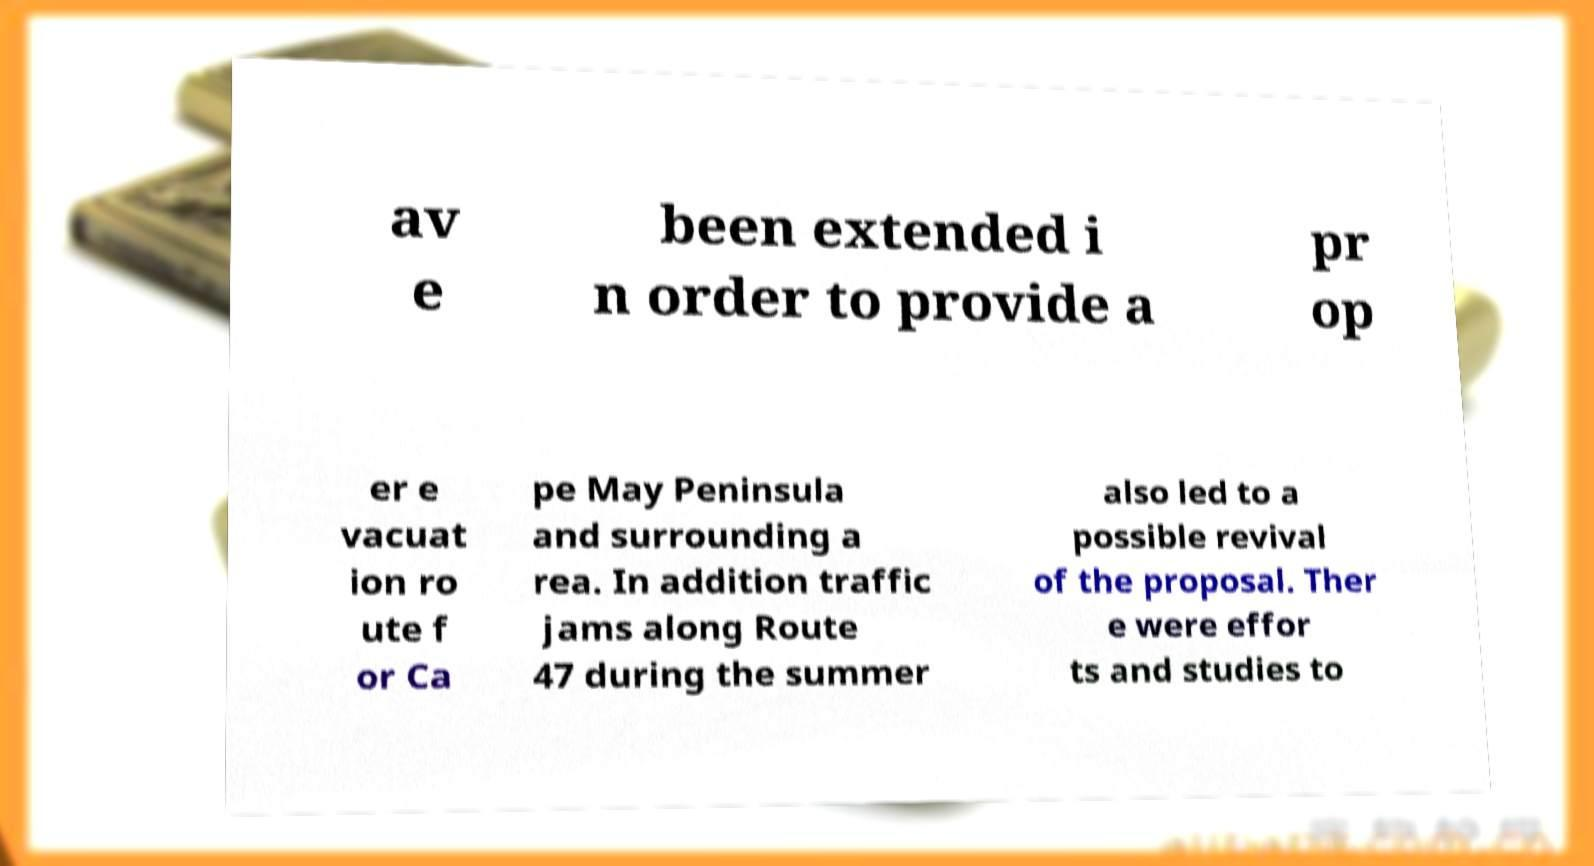Please read and relay the text visible in this image. What does it say? av e been extended i n order to provide a pr op er e vacuat ion ro ute f or Ca pe May Peninsula and surrounding a rea. In addition traffic jams along Route 47 during the summer also led to a possible revival of the proposal. Ther e were effor ts and studies to 